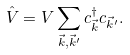Convert formula to latex. <formula><loc_0><loc_0><loc_500><loc_500>\hat { V } = V \sum _ { \vec { k } , \vec { k } ^ { \prime } } c ^ { \dagger } _ { \vec { k } } c _ { \vec { k } ^ { \prime } } .</formula> 